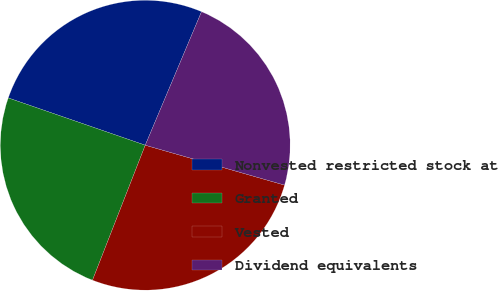Convert chart to OTSL. <chart><loc_0><loc_0><loc_500><loc_500><pie_chart><fcel>Nonvested restricted stock at<fcel>Granted<fcel>Vested<fcel>Dividend equivalents<nl><fcel>26.06%<fcel>24.36%<fcel>26.49%<fcel>23.09%<nl></chart> 